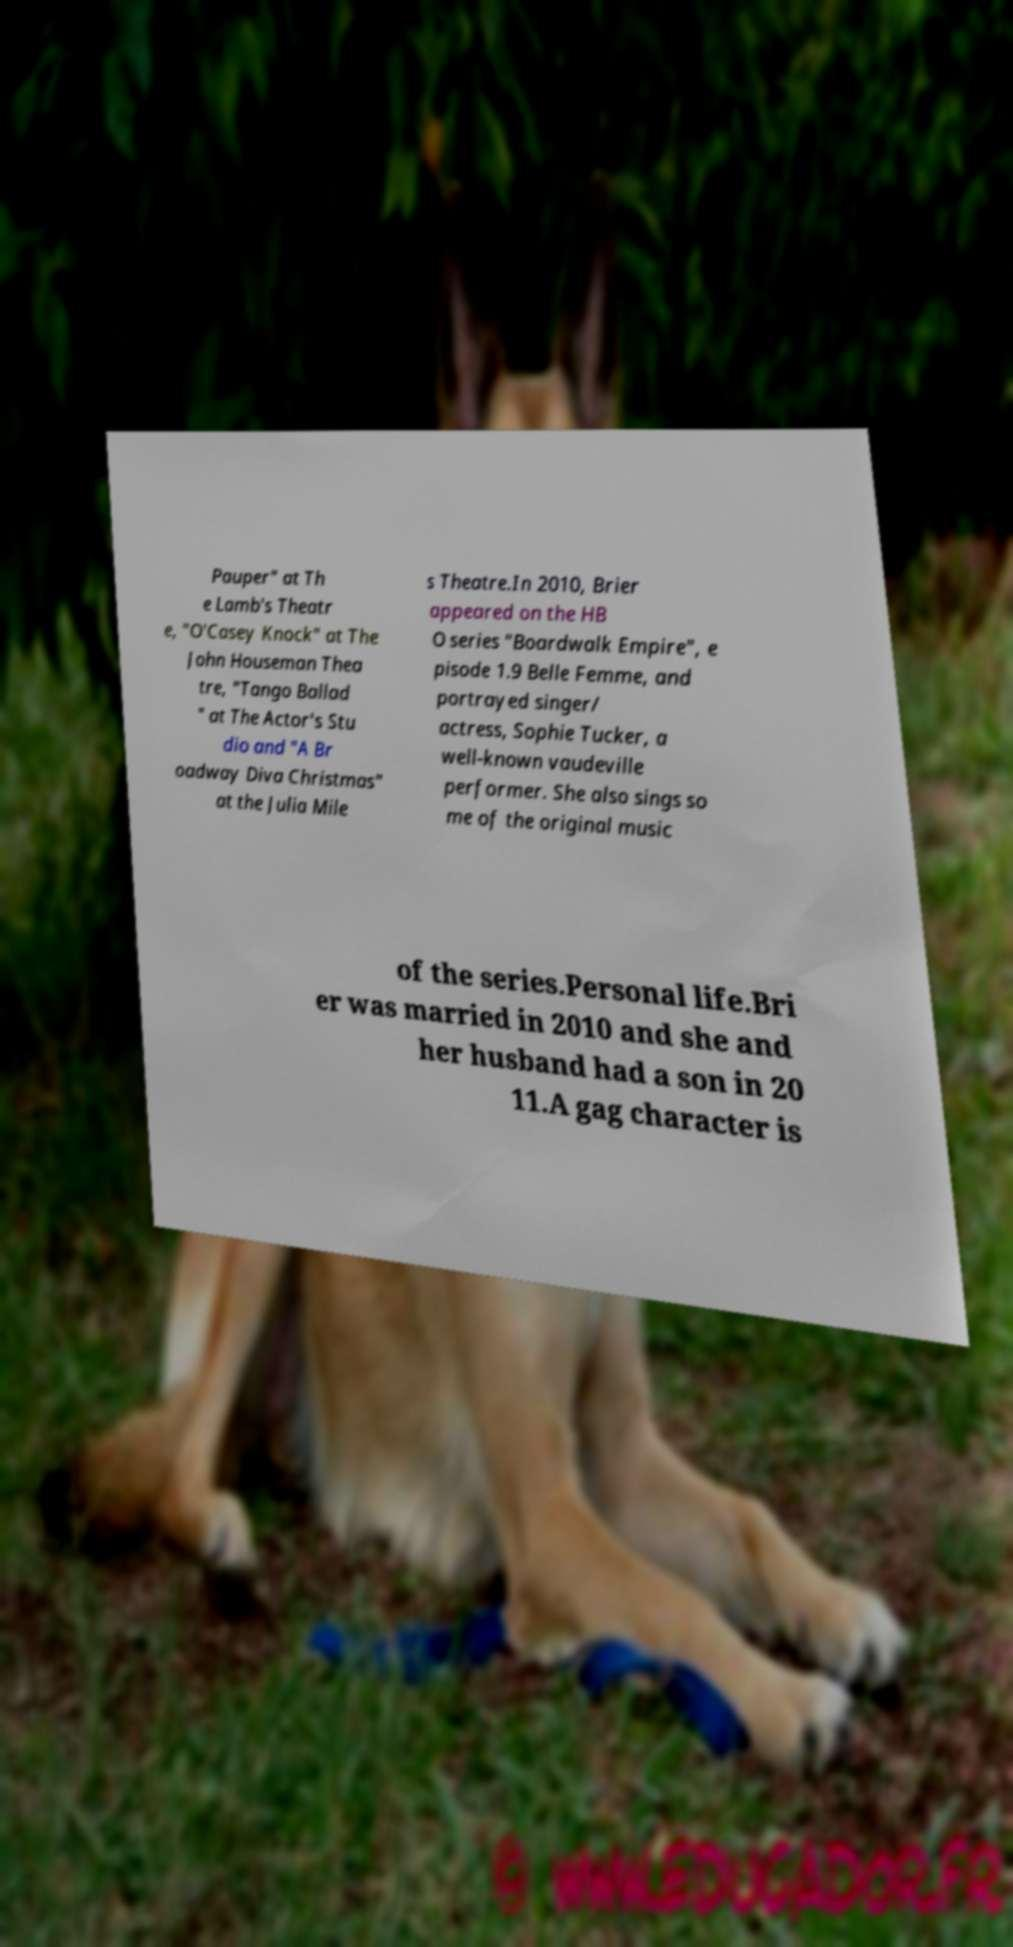Could you extract and type out the text from this image? Pauper" at Th e Lamb's Theatr e, "O'Casey Knock" at The John Houseman Thea tre, "Tango Ballad " at The Actor's Stu dio and "A Br oadway Diva Christmas" at the Julia Mile s Theatre.In 2010, Brier appeared on the HB O series "Boardwalk Empire", e pisode 1.9 Belle Femme, and portrayed singer/ actress, Sophie Tucker, a well-known vaudeville performer. She also sings so me of the original music of the series.Personal life.Bri er was married in 2010 and she and her husband had a son in 20 11.A gag character is 